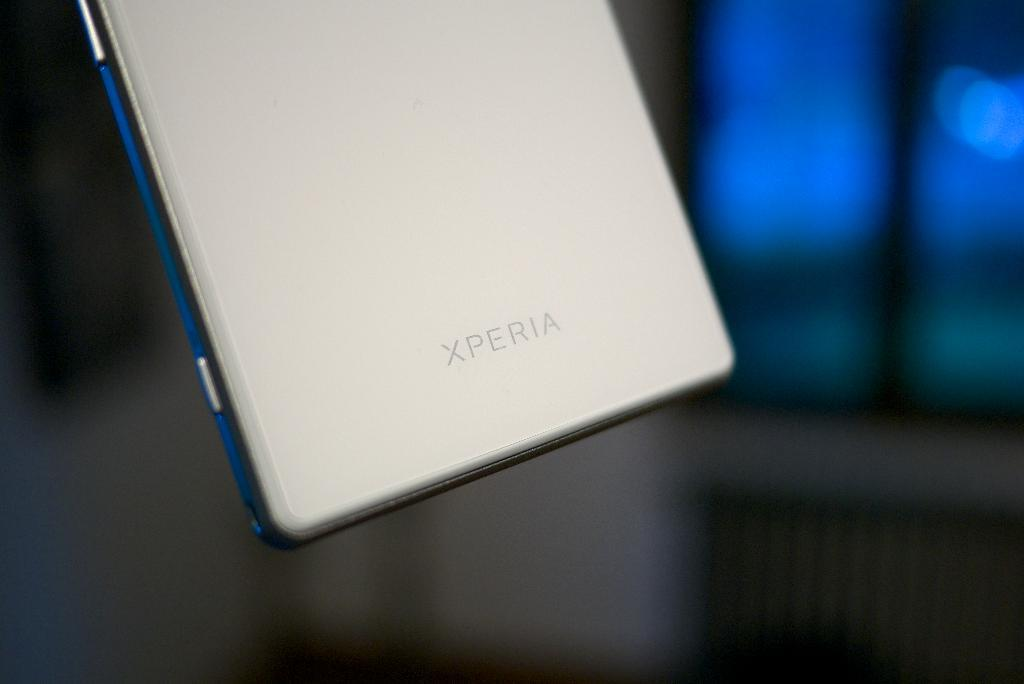<image>
Present a compact description of the photo's key features. the back of a silver xperia phone being held in midair 